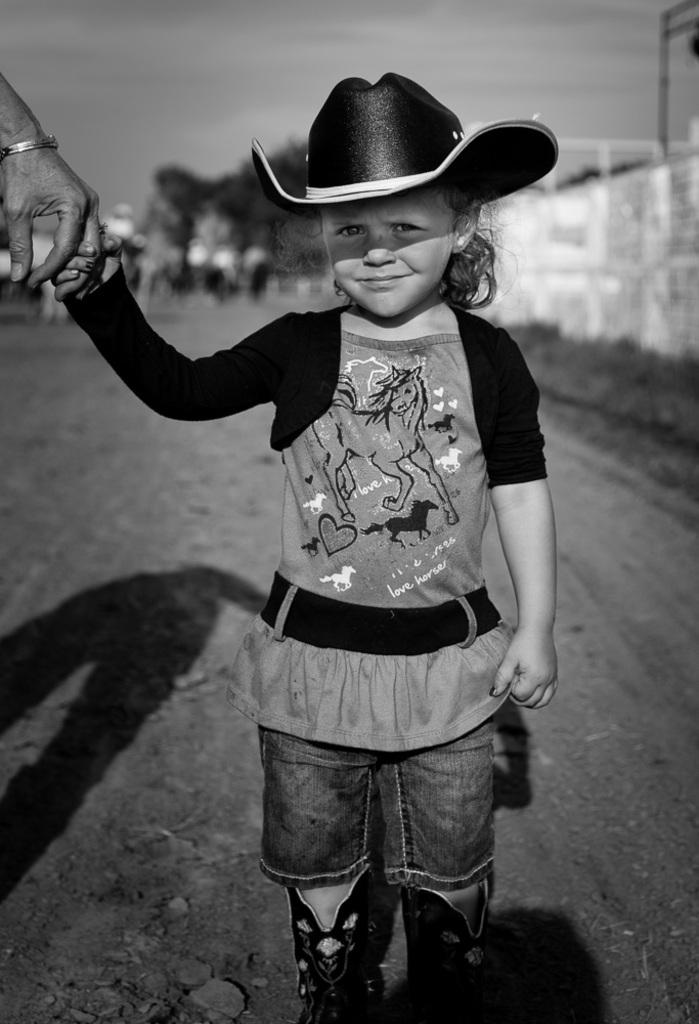What is the color scheme of the image? The image is black and white. What is the girl doing in the image? The girl is holding the finger of another person. Can you describe the background of the image? The background of the image is blurred. What type of crib is visible in the image? There is no crib present in the image. How does the rock affect the brain in the image? There is no rock or brain present in the image. 